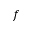Convert formula to latex. <formula><loc_0><loc_0><loc_500><loc_500>f</formula> 